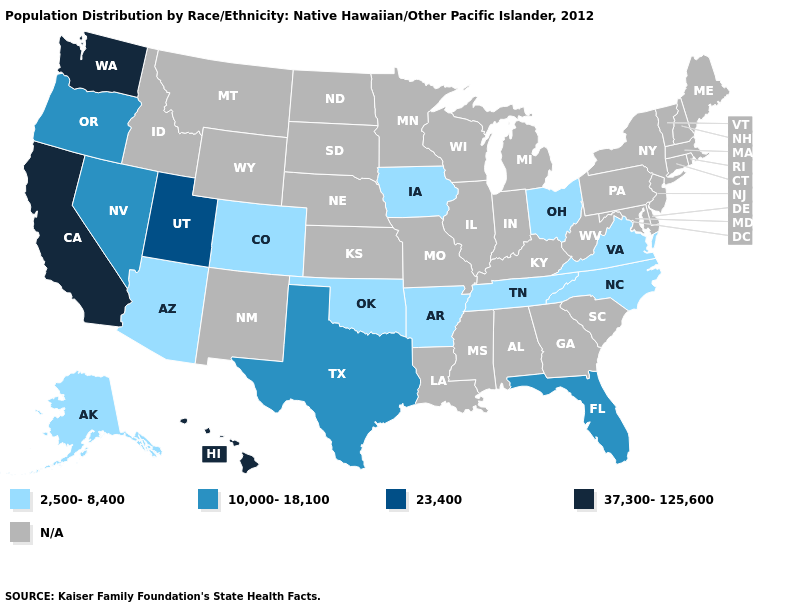What is the value of Maryland?
Give a very brief answer. N/A. What is the value of Oregon?
Be succinct. 10,000-18,100. Name the states that have a value in the range 23,400?
Answer briefly. Utah. How many symbols are there in the legend?
Answer briefly. 5. Name the states that have a value in the range N/A?
Quick response, please. Alabama, Connecticut, Delaware, Georgia, Idaho, Illinois, Indiana, Kansas, Kentucky, Louisiana, Maine, Maryland, Massachusetts, Michigan, Minnesota, Mississippi, Missouri, Montana, Nebraska, New Hampshire, New Jersey, New Mexico, New York, North Dakota, Pennsylvania, Rhode Island, South Carolina, South Dakota, Vermont, West Virginia, Wisconsin, Wyoming. Among the states that border Illinois , which have the lowest value?
Give a very brief answer. Iowa. Among the states that border Georgia , which have the highest value?
Concise answer only. Florida. Is the legend a continuous bar?
Keep it brief. No. Among the states that border Oklahoma , does Colorado have the lowest value?
Give a very brief answer. Yes. Which states have the highest value in the USA?
Concise answer only. California, Hawaii, Washington. What is the value of Georgia?
Be succinct. N/A. Does California have the highest value in the West?
Keep it brief. Yes. What is the lowest value in states that border Georgia?
Give a very brief answer. 2,500-8,400. What is the value of Maine?
Quick response, please. N/A. 